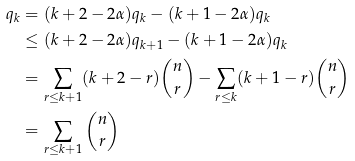<formula> <loc_0><loc_0><loc_500><loc_500>q _ { k } & = ( k + 2 - 2 \alpha ) q _ { k } - ( k + 1 - 2 \alpha ) q _ { k } \\ & \leq ( k + 2 - 2 \alpha ) q _ { k + 1 } - ( k + 1 - 2 \alpha ) q _ { k } \\ & = \sum _ { r \leq k + 1 } ( k + 2 - r ) \binom { n } { r } - \sum _ { r \leq k } ( k + 1 - r ) \binom { n } { r } \\ & = \sum _ { r \leq k + 1 } \binom { n } { r }</formula> 